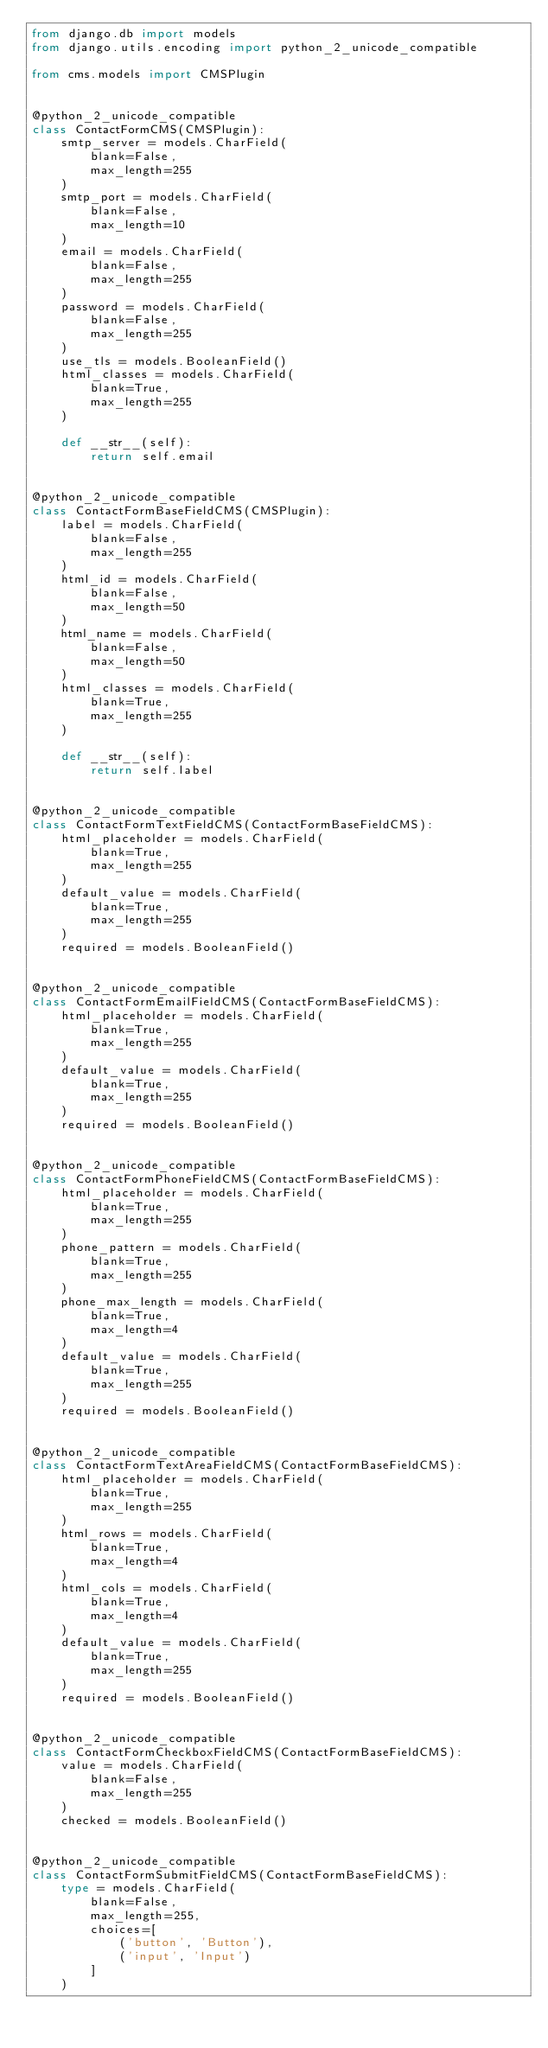Convert code to text. <code><loc_0><loc_0><loc_500><loc_500><_Python_>from django.db import models
from django.utils.encoding import python_2_unicode_compatible

from cms.models import CMSPlugin


@python_2_unicode_compatible
class ContactFormCMS(CMSPlugin):
    smtp_server = models.CharField(
        blank=False,
        max_length=255
    )
    smtp_port = models.CharField(
        blank=False,
        max_length=10
    )
    email = models.CharField(
        blank=False,
        max_length=255
    )
    password = models.CharField(
        blank=False,
        max_length=255
    )
    use_tls = models.BooleanField()
    html_classes = models.CharField(
        blank=True,
        max_length=255
    )

    def __str__(self):
        return self.email


@python_2_unicode_compatible
class ContactFormBaseFieldCMS(CMSPlugin):
    label = models.CharField(
        blank=False,
        max_length=255
    )
    html_id = models.CharField(
        blank=False,
        max_length=50
    )
    html_name = models.CharField(
        blank=False,
        max_length=50
    )
    html_classes = models.CharField(
        blank=True,
        max_length=255
    )

    def __str__(self):
        return self.label


@python_2_unicode_compatible
class ContactFormTextFieldCMS(ContactFormBaseFieldCMS):
    html_placeholder = models.CharField(
        blank=True,
        max_length=255
    )
    default_value = models.CharField(
        blank=True,
        max_length=255
    )
    required = models.BooleanField()


@python_2_unicode_compatible
class ContactFormEmailFieldCMS(ContactFormBaseFieldCMS):
    html_placeholder = models.CharField(
        blank=True,
        max_length=255
    )
    default_value = models.CharField(
        blank=True,
        max_length=255
    )
    required = models.BooleanField()


@python_2_unicode_compatible
class ContactFormPhoneFieldCMS(ContactFormBaseFieldCMS):
    html_placeholder = models.CharField(
        blank=True,
        max_length=255
    )
    phone_pattern = models.CharField(
        blank=True,
        max_length=255
    )
    phone_max_length = models.CharField(
        blank=True,
        max_length=4
    )
    default_value = models.CharField(
        blank=True,
        max_length=255
    )
    required = models.BooleanField()


@python_2_unicode_compatible
class ContactFormTextAreaFieldCMS(ContactFormBaseFieldCMS):
    html_placeholder = models.CharField(
        blank=True,
        max_length=255
    )
    html_rows = models.CharField(
        blank=True,
        max_length=4
    )
    html_cols = models.CharField(
        blank=True,
        max_length=4
    )
    default_value = models.CharField(
        blank=True,
        max_length=255
    )
    required = models.BooleanField()


@python_2_unicode_compatible
class ContactFormCheckboxFieldCMS(ContactFormBaseFieldCMS):
    value = models.CharField(
        blank=False,
        max_length=255
    )
    checked = models.BooleanField()


@python_2_unicode_compatible
class ContactFormSubmitFieldCMS(ContactFormBaseFieldCMS):
    type = models.CharField(
        blank=False,
        max_length=255,
        choices=[
            ('button', 'Button'),
            ('input', 'Input')
        ]
    )</code> 